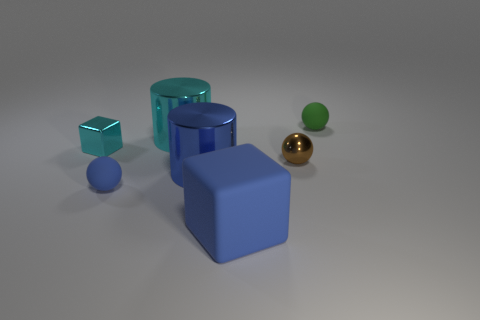Could you tell me about the lighting source in this scene? The lighting in this scene appears to be coming from above, casting soft shadows to the right of the objects, suggesting a single diffuse light source like a softbox or overhead light. The shadows are not sharply defined, which is consistent with a larger, diffused light source. 